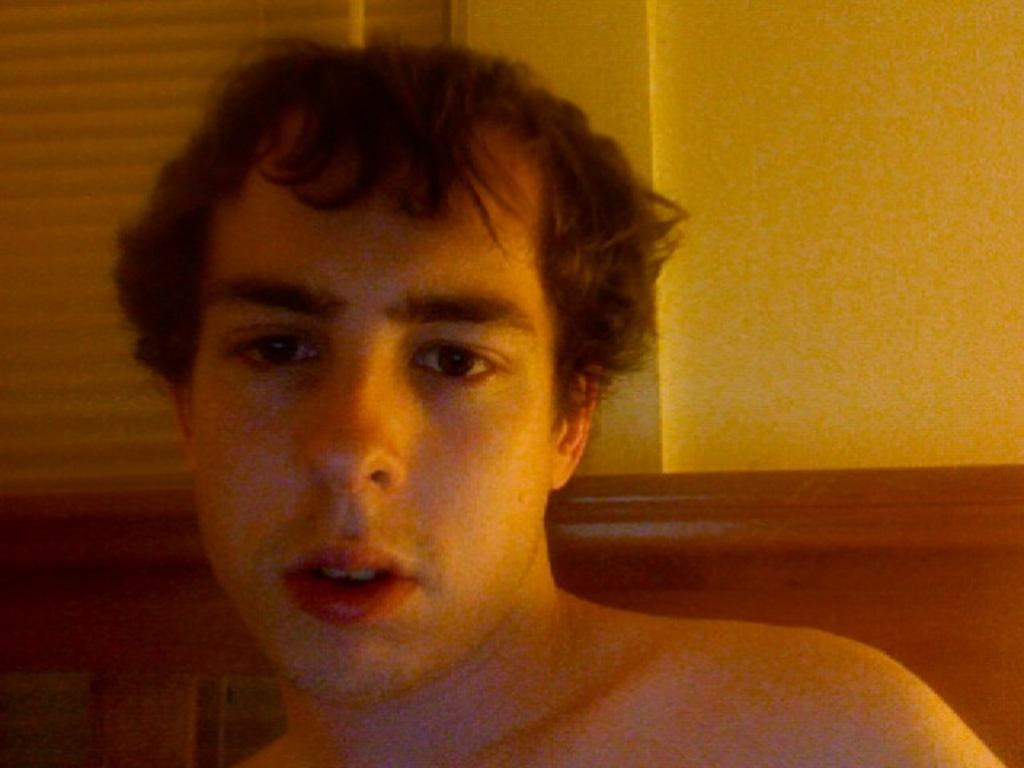Who or what is present in the image? There is a person in the image. What type of object can be seen in the image? There is a wooden object in the image. What is the background of the image? There is a wall in the image. Can you describe any other objects in the background? There is an object that looks like a window blind in the background of the image. What month is it in the image? The month cannot be determined from the image, as there is no information about the time or season. What type of game is being played in the image? There is no game being played in the image; it only features a person, a wooden object, a wall, and a window blind. 